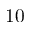<formula> <loc_0><loc_0><loc_500><loc_500>1 0</formula> 